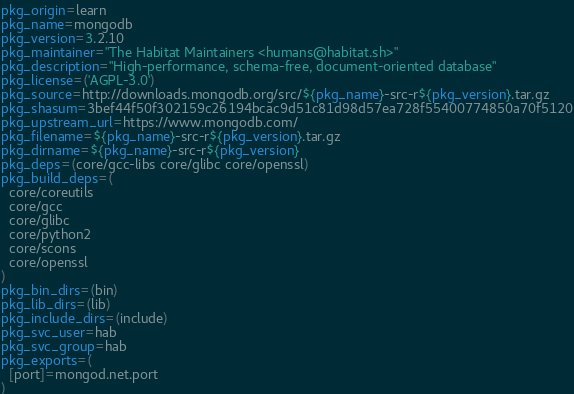<code> <loc_0><loc_0><loc_500><loc_500><_Bash_>pkg_origin=learn
pkg_name=mongodb
pkg_version=3.2.10
pkg_maintainer="The Habitat Maintainers <humans@habitat.sh>"
pkg_description="High-performance, schema-free, document-oriented database"
pkg_license=('AGPL-3.0')
pkg_source=http://downloads.mongodb.org/src/${pkg_name}-src-r${pkg_version}.tar.gz
pkg_shasum=3bef44f50f302159c26194bcac9d51c81d98d57ea728f55400774850a70f5120
pkg_upstream_url=https://www.mongodb.com/
pkg_filename=${pkg_name}-src-r${pkg_version}.tar.gz
pkg_dirname=${pkg_name}-src-r${pkg_version}
pkg_deps=(core/gcc-libs core/glibc core/openssl)
pkg_build_deps=(
  core/coreutils
  core/gcc
  core/glibc
  core/python2
  core/scons
  core/openssl
)
pkg_bin_dirs=(bin)
pkg_lib_dirs=(lib)
pkg_include_dirs=(include)
pkg_svc_user=hab
pkg_svc_group=hab
pkg_exports=(
  [port]=mongod.net.port
)</code> 